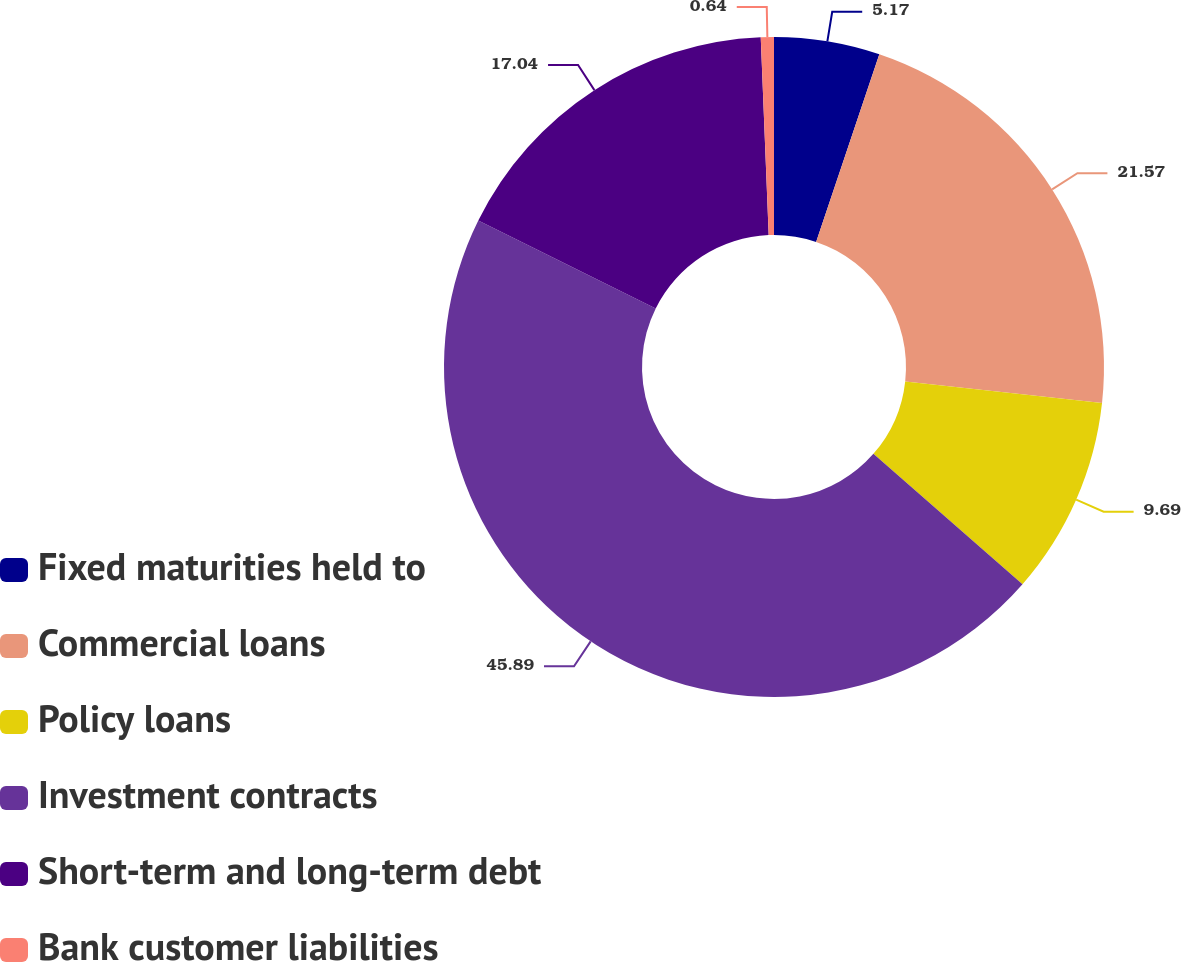<chart> <loc_0><loc_0><loc_500><loc_500><pie_chart><fcel>Fixed maturities held to<fcel>Commercial loans<fcel>Policy loans<fcel>Investment contracts<fcel>Short-term and long-term debt<fcel>Bank customer liabilities<nl><fcel>5.17%<fcel>21.57%<fcel>9.69%<fcel>45.89%<fcel>17.04%<fcel>0.64%<nl></chart> 